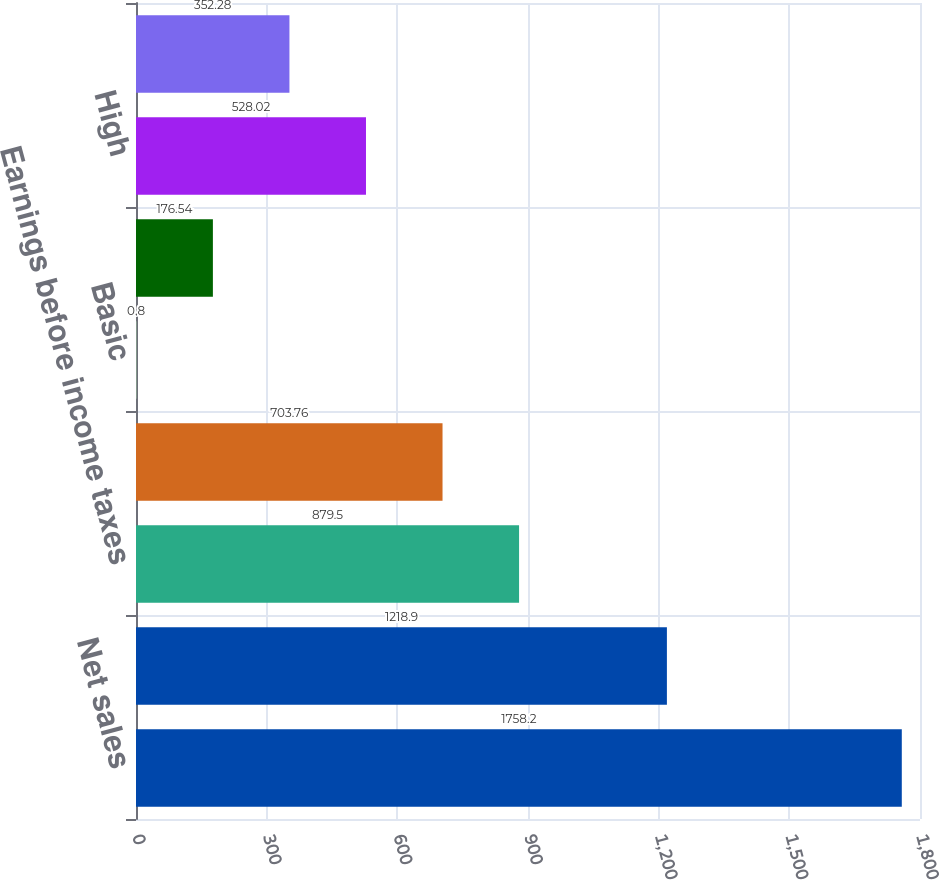Convert chart to OTSL. <chart><loc_0><loc_0><loc_500><loc_500><bar_chart><fcel>Net sales<fcel>Gross profit<fcel>Earnings before income taxes<fcel>Net earnings<fcel>Basic<fcel>Diluted<fcel>High<fcel>Low<nl><fcel>1758.2<fcel>1218.9<fcel>879.5<fcel>703.76<fcel>0.8<fcel>176.54<fcel>528.02<fcel>352.28<nl></chart> 